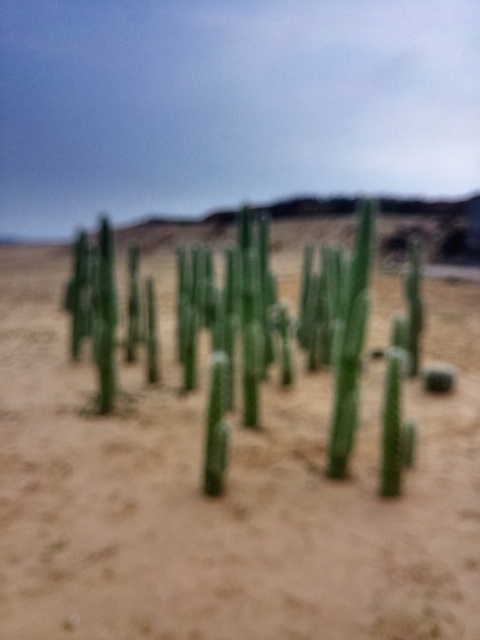What might be the reason for the photo's blurriness? The blurriness could be due to several factors, including camera shake, incorrect focus point selection, a low shutter speed in low light conditions, or the photographer intentionally creating an abstract effect. 